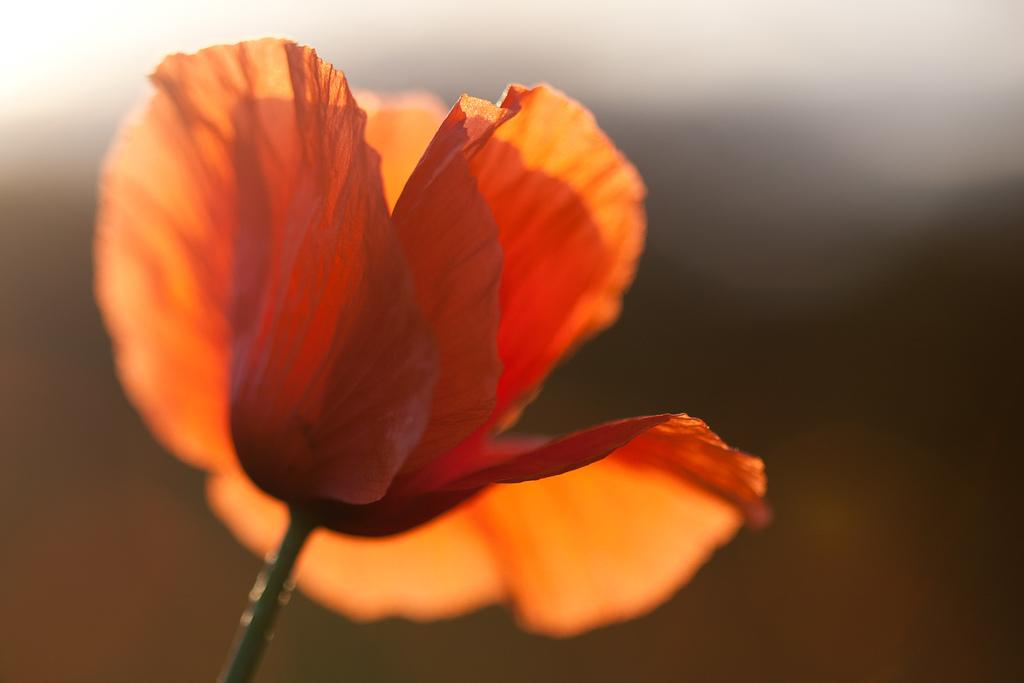What is the main subject of the image? The main subject of the image is a flower. Can you describe the color of the flower? The flower is in saffron color. What type of protest is happening in the image? There is no protest present in the image; it only features a saffron-colored flower. How many cars are visible in the image? There are no cars present in the image; it only features a saffron-colored flower. 